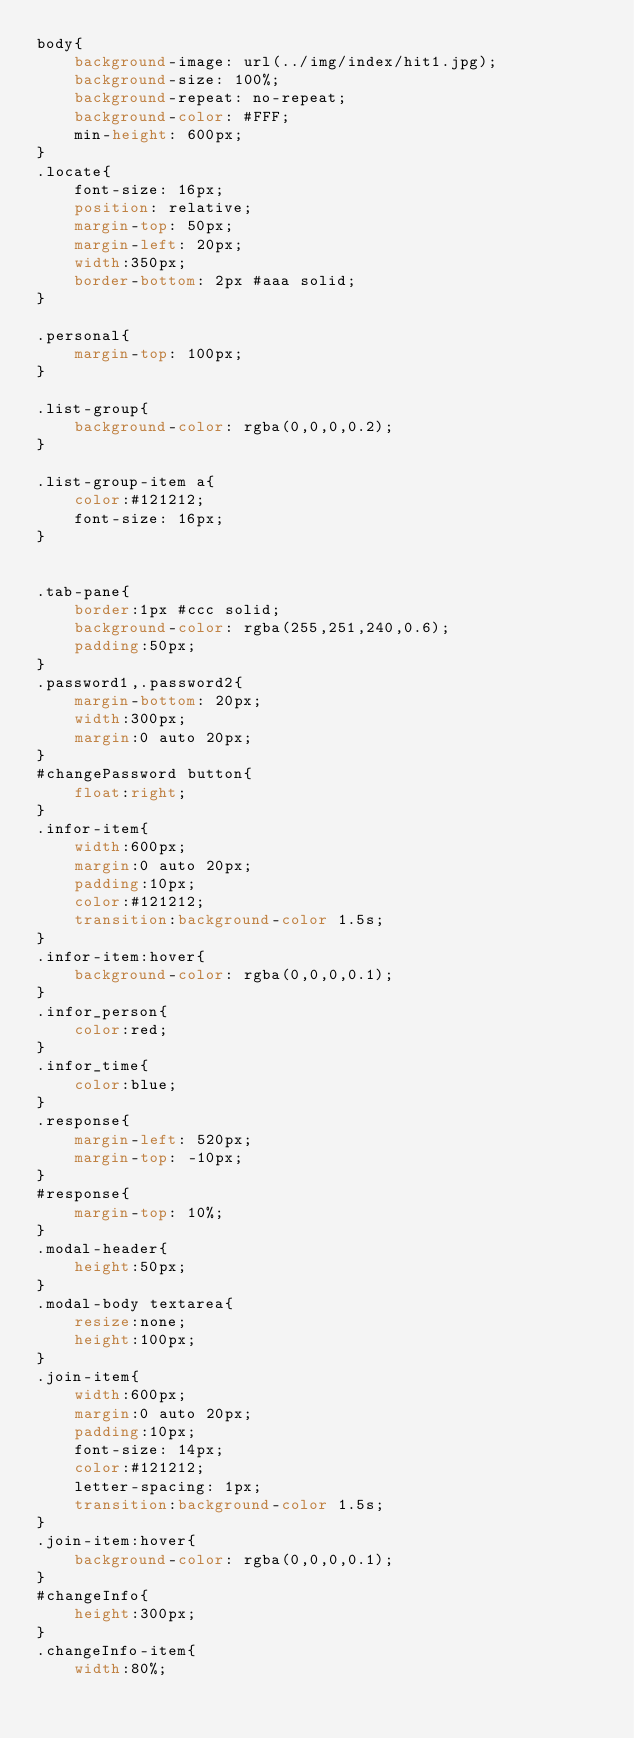<code> <loc_0><loc_0><loc_500><loc_500><_CSS_>body{
	background-image: url(../img/index/hit1.jpg);
	background-size: 100%;
	background-repeat: no-repeat;
	background-color: #FFF;
	min-height: 600px;
}
.locate{
	font-size: 16px;
	position: relative;
	margin-top: 50px;
	margin-left: 20px;
	width:350px;
	border-bottom: 2px #aaa solid;
}

.personal{
	margin-top: 100px;
}

.list-group{
	background-color: rgba(0,0,0,0.2);
}

.list-group-item a{
	color:#121212;
	font-size: 16px;
}


.tab-pane{
	border:1px #ccc solid;
	background-color: rgba(255,251,240,0.6);
	padding:50px;
}
.password1,.password2{
	margin-bottom: 20px;
	width:300px;
	margin:0 auto 20px;
}
#changePassword button{
	float:right;
}
.infor-item{
	width:600px;
	margin:0 auto 20px;
	padding:10px;
	color:#121212;
	transition:background-color 1.5s;
}
.infor-item:hover{
	background-color: rgba(0,0,0,0.1);
}
.infor_person{
	color:red;
}
.infor_time{
	color:blue;
}
.response{
	margin-left: 520px;
	margin-top: -10px;
}
#response{
	margin-top: 10%;
}
.modal-header{
	height:50px;
}
.modal-body textarea{
	resize:none;
	height:100px;
}
.join-item{
	width:600px;
	margin:0 auto 20px;
	padding:10px;
	font-size: 14px;
	color:#121212;
	letter-spacing: 1px;
	transition:background-color 1.5s;
}
.join-item:hover{
	background-color: rgba(0,0,0,0.1);
}
#changeInfo{
	height:300px;
}
.changeInfo-item{
	width:80%;</code> 